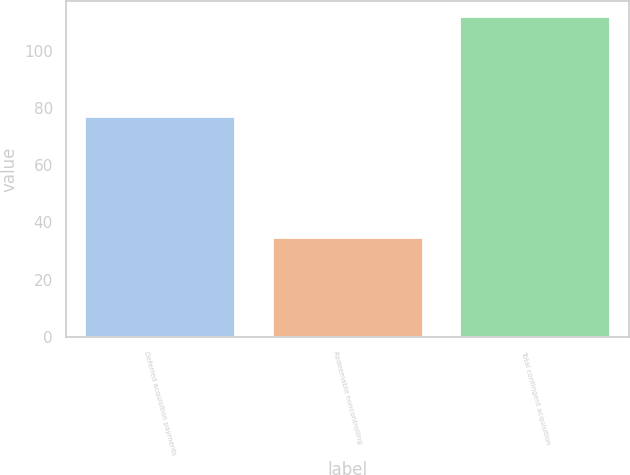Convert chart. <chart><loc_0><loc_0><loc_500><loc_500><bar_chart><fcel>Deferred acquisition payments<fcel>Redeemable noncontrolling<fcel>Total contingent acquisition<nl><fcel>76.9<fcel>34.7<fcel>111.6<nl></chart> 